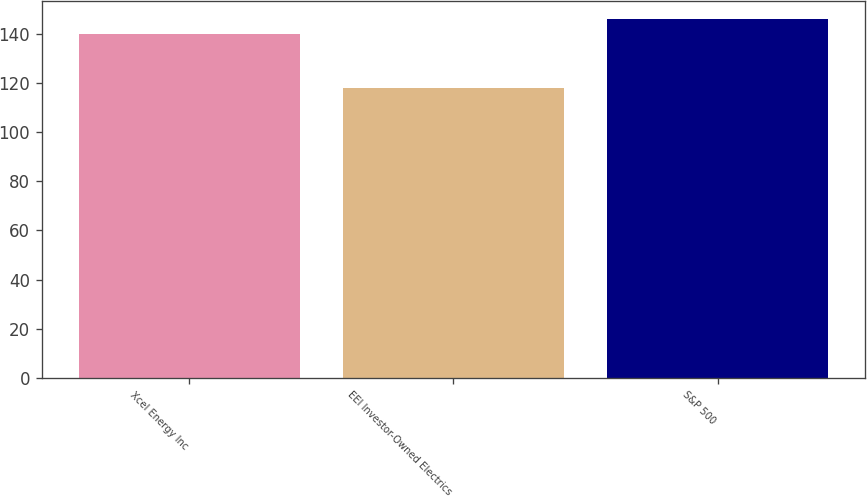Convert chart. <chart><loc_0><loc_0><loc_500><loc_500><bar_chart><fcel>Xcel Energy Inc<fcel>EEI Investor-Owned Electrics<fcel>S&P 500<nl><fcel>140<fcel>118<fcel>146<nl></chart> 